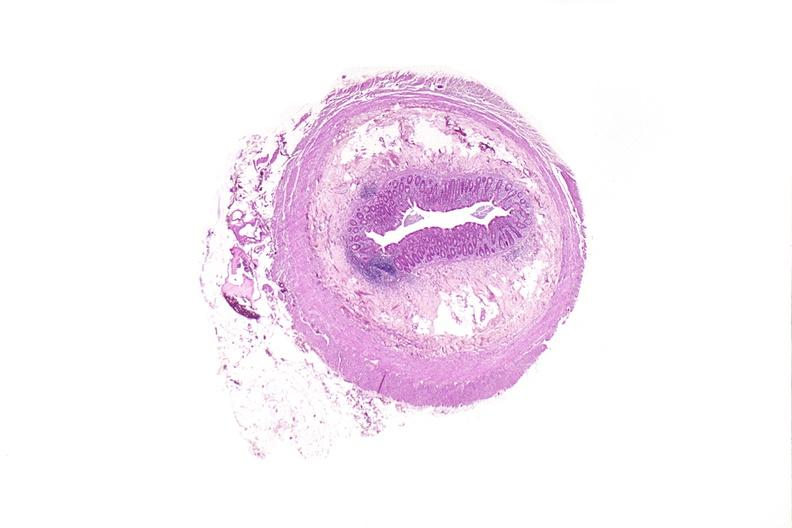does this image show appendix, normal histology?
Answer the question using a single word or phrase. Yes 